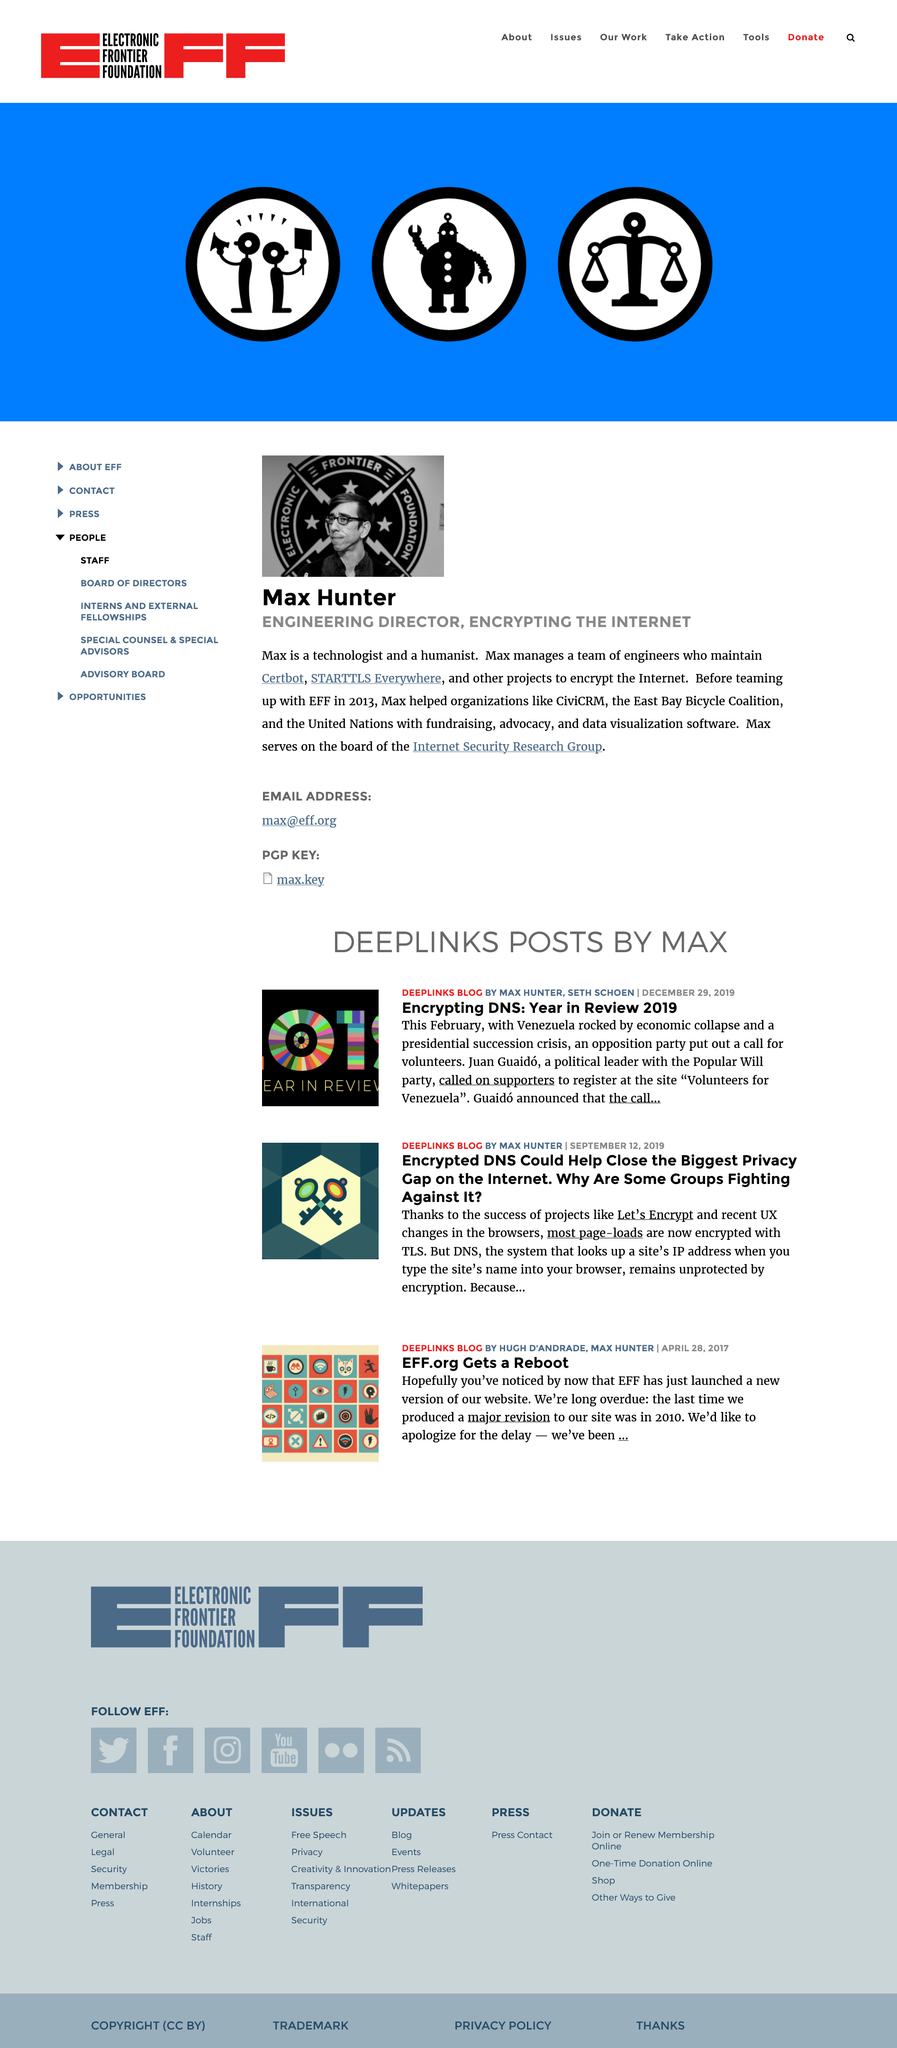Indicate a few pertinent items in this graphic. Max Hunter is his surname. The earliest result was published on April 28th, 2017. DeepLinks is a blog that provides information on various topics related to technology, including artificial intelligence, virtual assistants, and deep links. 